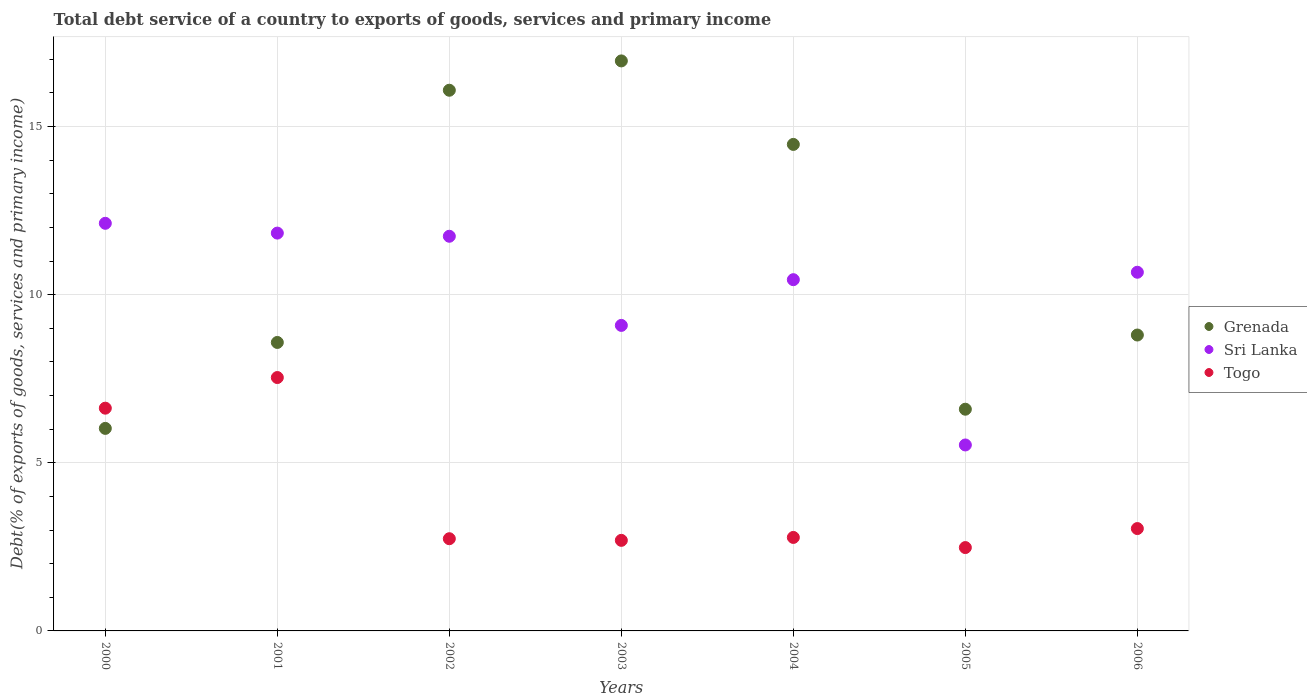What is the total debt service in Sri Lanka in 2002?
Make the answer very short. 11.74. Across all years, what is the maximum total debt service in Sri Lanka?
Offer a very short reply. 12.12. Across all years, what is the minimum total debt service in Sri Lanka?
Keep it short and to the point. 5.53. In which year was the total debt service in Grenada maximum?
Offer a terse response. 2003. In which year was the total debt service in Grenada minimum?
Offer a very short reply. 2000. What is the total total debt service in Sri Lanka in the graph?
Keep it short and to the point. 71.42. What is the difference between the total debt service in Grenada in 2002 and that in 2005?
Provide a succinct answer. 9.49. What is the difference between the total debt service in Togo in 2006 and the total debt service in Grenada in 2003?
Your answer should be very brief. -13.91. What is the average total debt service in Sri Lanka per year?
Provide a short and direct response. 10.2. In the year 2006, what is the difference between the total debt service in Togo and total debt service in Sri Lanka?
Make the answer very short. -7.62. In how many years, is the total debt service in Sri Lanka greater than 11 %?
Provide a short and direct response. 3. What is the ratio of the total debt service in Togo in 2000 to that in 2006?
Give a very brief answer. 2.18. Is the total debt service in Sri Lanka in 2003 less than that in 2006?
Your answer should be very brief. Yes. Is the difference between the total debt service in Togo in 2004 and 2005 greater than the difference between the total debt service in Sri Lanka in 2004 and 2005?
Your response must be concise. No. What is the difference between the highest and the second highest total debt service in Grenada?
Offer a very short reply. 0.87. What is the difference between the highest and the lowest total debt service in Grenada?
Your response must be concise. 10.93. In how many years, is the total debt service in Togo greater than the average total debt service in Togo taken over all years?
Keep it short and to the point. 2. Is the sum of the total debt service in Togo in 2002 and 2005 greater than the maximum total debt service in Grenada across all years?
Provide a short and direct response. No. How many dotlines are there?
Provide a succinct answer. 3. Where does the legend appear in the graph?
Keep it short and to the point. Center right. How many legend labels are there?
Ensure brevity in your answer.  3. How are the legend labels stacked?
Provide a short and direct response. Vertical. What is the title of the graph?
Your answer should be very brief. Total debt service of a country to exports of goods, services and primary income. Does "New Caledonia" appear as one of the legend labels in the graph?
Offer a terse response. No. What is the label or title of the Y-axis?
Give a very brief answer. Debt(% of exports of goods, services and primary income). What is the Debt(% of exports of goods, services and primary income) in Grenada in 2000?
Offer a terse response. 6.02. What is the Debt(% of exports of goods, services and primary income) of Sri Lanka in 2000?
Keep it short and to the point. 12.12. What is the Debt(% of exports of goods, services and primary income) in Togo in 2000?
Give a very brief answer. 6.62. What is the Debt(% of exports of goods, services and primary income) of Grenada in 2001?
Make the answer very short. 8.58. What is the Debt(% of exports of goods, services and primary income) in Sri Lanka in 2001?
Your response must be concise. 11.83. What is the Debt(% of exports of goods, services and primary income) of Togo in 2001?
Offer a very short reply. 7.54. What is the Debt(% of exports of goods, services and primary income) of Grenada in 2002?
Your answer should be very brief. 16.08. What is the Debt(% of exports of goods, services and primary income) in Sri Lanka in 2002?
Your answer should be very brief. 11.74. What is the Debt(% of exports of goods, services and primary income) of Togo in 2002?
Make the answer very short. 2.74. What is the Debt(% of exports of goods, services and primary income) of Grenada in 2003?
Keep it short and to the point. 16.95. What is the Debt(% of exports of goods, services and primary income) of Sri Lanka in 2003?
Provide a short and direct response. 9.09. What is the Debt(% of exports of goods, services and primary income) in Togo in 2003?
Provide a succinct answer. 2.69. What is the Debt(% of exports of goods, services and primary income) of Grenada in 2004?
Give a very brief answer. 14.47. What is the Debt(% of exports of goods, services and primary income) of Sri Lanka in 2004?
Offer a terse response. 10.45. What is the Debt(% of exports of goods, services and primary income) in Togo in 2004?
Keep it short and to the point. 2.78. What is the Debt(% of exports of goods, services and primary income) in Grenada in 2005?
Provide a succinct answer. 6.59. What is the Debt(% of exports of goods, services and primary income) in Sri Lanka in 2005?
Give a very brief answer. 5.53. What is the Debt(% of exports of goods, services and primary income) of Togo in 2005?
Make the answer very short. 2.48. What is the Debt(% of exports of goods, services and primary income) in Grenada in 2006?
Make the answer very short. 8.8. What is the Debt(% of exports of goods, services and primary income) in Sri Lanka in 2006?
Ensure brevity in your answer.  10.67. What is the Debt(% of exports of goods, services and primary income) of Togo in 2006?
Your response must be concise. 3.04. Across all years, what is the maximum Debt(% of exports of goods, services and primary income) in Grenada?
Provide a succinct answer. 16.95. Across all years, what is the maximum Debt(% of exports of goods, services and primary income) of Sri Lanka?
Make the answer very short. 12.12. Across all years, what is the maximum Debt(% of exports of goods, services and primary income) in Togo?
Your answer should be very brief. 7.54. Across all years, what is the minimum Debt(% of exports of goods, services and primary income) of Grenada?
Give a very brief answer. 6.02. Across all years, what is the minimum Debt(% of exports of goods, services and primary income) in Sri Lanka?
Offer a very short reply. 5.53. Across all years, what is the minimum Debt(% of exports of goods, services and primary income) of Togo?
Provide a short and direct response. 2.48. What is the total Debt(% of exports of goods, services and primary income) in Grenada in the graph?
Offer a very short reply. 77.5. What is the total Debt(% of exports of goods, services and primary income) of Sri Lanka in the graph?
Provide a short and direct response. 71.42. What is the total Debt(% of exports of goods, services and primary income) in Togo in the graph?
Offer a terse response. 27.9. What is the difference between the Debt(% of exports of goods, services and primary income) in Grenada in 2000 and that in 2001?
Offer a terse response. -2.56. What is the difference between the Debt(% of exports of goods, services and primary income) in Sri Lanka in 2000 and that in 2001?
Ensure brevity in your answer.  0.29. What is the difference between the Debt(% of exports of goods, services and primary income) in Togo in 2000 and that in 2001?
Provide a succinct answer. -0.91. What is the difference between the Debt(% of exports of goods, services and primary income) of Grenada in 2000 and that in 2002?
Your answer should be compact. -10.06. What is the difference between the Debt(% of exports of goods, services and primary income) in Sri Lanka in 2000 and that in 2002?
Provide a succinct answer. 0.39. What is the difference between the Debt(% of exports of goods, services and primary income) of Togo in 2000 and that in 2002?
Provide a short and direct response. 3.88. What is the difference between the Debt(% of exports of goods, services and primary income) of Grenada in 2000 and that in 2003?
Provide a short and direct response. -10.93. What is the difference between the Debt(% of exports of goods, services and primary income) in Sri Lanka in 2000 and that in 2003?
Provide a short and direct response. 3.04. What is the difference between the Debt(% of exports of goods, services and primary income) of Togo in 2000 and that in 2003?
Keep it short and to the point. 3.93. What is the difference between the Debt(% of exports of goods, services and primary income) in Grenada in 2000 and that in 2004?
Offer a very short reply. -8.45. What is the difference between the Debt(% of exports of goods, services and primary income) of Sri Lanka in 2000 and that in 2004?
Make the answer very short. 1.68. What is the difference between the Debt(% of exports of goods, services and primary income) of Togo in 2000 and that in 2004?
Your answer should be compact. 3.84. What is the difference between the Debt(% of exports of goods, services and primary income) of Grenada in 2000 and that in 2005?
Provide a short and direct response. -0.57. What is the difference between the Debt(% of exports of goods, services and primary income) in Sri Lanka in 2000 and that in 2005?
Make the answer very short. 6.59. What is the difference between the Debt(% of exports of goods, services and primary income) of Togo in 2000 and that in 2005?
Make the answer very short. 4.15. What is the difference between the Debt(% of exports of goods, services and primary income) in Grenada in 2000 and that in 2006?
Provide a short and direct response. -2.78. What is the difference between the Debt(% of exports of goods, services and primary income) of Sri Lanka in 2000 and that in 2006?
Your answer should be very brief. 1.46. What is the difference between the Debt(% of exports of goods, services and primary income) of Togo in 2000 and that in 2006?
Keep it short and to the point. 3.58. What is the difference between the Debt(% of exports of goods, services and primary income) in Grenada in 2001 and that in 2002?
Keep it short and to the point. -7.5. What is the difference between the Debt(% of exports of goods, services and primary income) of Sri Lanka in 2001 and that in 2002?
Provide a succinct answer. 0.09. What is the difference between the Debt(% of exports of goods, services and primary income) of Togo in 2001 and that in 2002?
Offer a terse response. 4.79. What is the difference between the Debt(% of exports of goods, services and primary income) of Grenada in 2001 and that in 2003?
Your answer should be compact. -8.37. What is the difference between the Debt(% of exports of goods, services and primary income) of Sri Lanka in 2001 and that in 2003?
Offer a very short reply. 2.75. What is the difference between the Debt(% of exports of goods, services and primary income) in Togo in 2001 and that in 2003?
Offer a very short reply. 4.84. What is the difference between the Debt(% of exports of goods, services and primary income) of Grenada in 2001 and that in 2004?
Make the answer very short. -5.89. What is the difference between the Debt(% of exports of goods, services and primary income) in Sri Lanka in 2001 and that in 2004?
Provide a succinct answer. 1.39. What is the difference between the Debt(% of exports of goods, services and primary income) of Togo in 2001 and that in 2004?
Ensure brevity in your answer.  4.76. What is the difference between the Debt(% of exports of goods, services and primary income) of Grenada in 2001 and that in 2005?
Your answer should be very brief. 1.99. What is the difference between the Debt(% of exports of goods, services and primary income) in Sri Lanka in 2001 and that in 2005?
Provide a succinct answer. 6.3. What is the difference between the Debt(% of exports of goods, services and primary income) of Togo in 2001 and that in 2005?
Provide a succinct answer. 5.06. What is the difference between the Debt(% of exports of goods, services and primary income) of Grenada in 2001 and that in 2006?
Your response must be concise. -0.22. What is the difference between the Debt(% of exports of goods, services and primary income) of Sri Lanka in 2001 and that in 2006?
Your answer should be compact. 1.16. What is the difference between the Debt(% of exports of goods, services and primary income) of Togo in 2001 and that in 2006?
Your response must be concise. 4.49. What is the difference between the Debt(% of exports of goods, services and primary income) of Grenada in 2002 and that in 2003?
Your response must be concise. -0.87. What is the difference between the Debt(% of exports of goods, services and primary income) in Sri Lanka in 2002 and that in 2003?
Your answer should be compact. 2.65. What is the difference between the Debt(% of exports of goods, services and primary income) in Togo in 2002 and that in 2003?
Your response must be concise. 0.05. What is the difference between the Debt(% of exports of goods, services and primary income) in Grenada in 2002 and that in 2004?
Offer a very short reply. 1.61. What is the difference between the Debt(% of exports of goods, services and primary income) in Sri Lanka in 2002 and that in 2004?
Make the answer very short. 1.29. What is the difference between the Debt(% of exports of goods, services and primary income) of Togo in 2002 and that in 2004?
Keep it short and to the point. -0.04. What is the difference between the Debt(% of exports of goods, services and primary income) in Grenada in 2002 and that in 2005?
Keep it short and to the point. 9.49. What is the difference between the Debt(% of exports of goods, services and primary income) in Sri Lanka in 2002 and that in 2005?
Provide a succinct answer. 6.21. What is the difference between the Debt(% of exports of goods, services and primary income) in Togo in 2002 and that in 2005?
Your answer should be compact. 0.26. What is the difference between the Debt(% of exports of goods, services and primary income) in Grenada in 2002 and that in 2006?
Your response must be concise. 7.28. What is the difference between the Debt(% of exports of goods, services and primary income) in Sri Lanka in 2002 and that in 2006?
Ensure brevity in your answer.  1.07. What is the difference between the Debt(% of exports of goods, services and primary income) of Togo in 2002 and that in 2006?
Offer a terse response. -0.3. What is the difference between the Debt(% of exports of goods, services and primary income) of Grenada in 2003 and that in 2004?
Ensure brevity in your answer.  2.48. What is the difference between the Debt(% of exports of goods, services and primary income) in Sri Lanka in 2003 and that in 2004?
Your answer should be very brief. -1.36. What is the difference between the Debt(% of exports of goods, services and primary income) of Togo in 2003 and that in 2004?
Offer a terse response. -0.09. What is the difference between the Debt(% of exports of goods, services and primary income) in Grenada in 2003 and that in 2005?
Keep it short and to the point. 10.36. What is the difference between the Debt(% of exports of goods, services and primary income) of Sri Lanka in 2003 and that in 2005?
Ensure brevity in your answer.  3.56. What is the difference between the Debt(% of exports of goods, services and primary income) in Togo in 2003 and that in 2005?
Your response must be concise. 0.21. What is the difference between the Debt(% of exports of goods, services and primary income) of Grenada in 2003 and that in 2006?
Provide a short and direct response. 8.15. What is the difference between the Debt(% of exports of goods, services and primary income) in Sri Lanka in 2003 and that in 2006?
Make the answer very short. -1.58. What is the difference between the Debt(% of exports of goods, services and primary income) in Togo in 2003 and that in 2006?
Ensure brevity in your answer.  -0.35. What is the difference between the Debt(% of exports of goods, services and primary income) in Grenada in 2004 and that in 2005?
Provide a succinct answer. 7.88. What is the difference between the Debt(% of exports of goods, services and primary income) in Sri Lanka in 2004 and that in 2005?
Provide a short and direct response. 4.92. What is the difference between the Debt(% of exports of goods, services and primary income) in Togo in 2004 and that in 2005?
Provide a succinct answer. 0.3. What is the difference between the Debt(% of exports of goods, services and primary income) of Grenada in 2004 and that in 2006?
Make the answer very short. 5.67. What is the difference between the Debt(% of exports of goods, services and primary income) of Sri Lanka in 2004 and that in 2006?
Provide a succinct answer. -0.22. What is the difference between the Debt(% of exports of goods, services and primary income) in Togo in 2004 and that in 2006?
Offer a terse response. -0.26. What is the difference between the Debt(% of exports of goods, services and primary income) of Grenada in 2005 and that in 2006?
Offer a terse response. -2.21. What is the difference between the Debt(% of exports of goods, services and primary income) of Sri Lanka in 2005 and that in 2006?
Your response must be concise. -5.14. What is the difference between the Debt(% of exports of goods, services and primary income) in Togo in 2005 and that in 2006?
Offer a very short reply. -0.57. What is the difference between the Debt(% of exports of goods, services and primary income) in Grenada in 2000 and the Debt(% of exports of goods, services and primary income) in Sri Lanka in 2001?
Provide a succinct answer. -5.81. What is the difference between the Debt(% of exports of goods, services and primary income) in Grenada in 2000 and the Debt(% of exports of goods, services and primary income) in Togo in 2001?
Your answer should be compact. -1.51. What is the difference between the Debt(% of exports of goods, services and primary income) of Sri Lanka in 2000 and the Debt(% of exports of goods, services and primary income) of Togo in 2001?
Keep it short and to the point. 4.59. What is the difference between the Debt(% of exports of goods, services and primary income) of Grenada in 2000 and the Debt(% of exports of goods, services and primary income) of Sri Lanka in 2002?
Give a very brief answer. -5.71. What is the difference between the Debt(% of exports of goods, services and primary income) of Grenada in 2000 and the Debt(% of exports of goods, services and primary income) of Togo in 2002?
Your response must be concise. 3.28. What is the difference between the Debt(% of exports of goods, services and primary income) in Sri Lanka in 2000 and the Debt(% of exports of goods, services and primary income) in Togo in 2002?
Your answer should be very brief. 9.38. What is the difference between the Debt(% of exports of goods, services and primary income) in Grenada in 2000 and the Debt(% of exports of goods, services and primary income) in Sri Lanka in 2003?
Give a very brief answer. -3.06. What is the difference between the Debt(% of exports of goods, services and primary income) of Grenada in 2000 and the Debt(% of exports of goods, services and primary income) of Togo in 2003?
Your answer should be very brief. 3.33. What is the difference between the Debt(% of exports of goods, services and primary income) in Sri Lanka in 2000 and the Debt(% of exports of goods, services and primary income) in Togo in 2003?
Your answer should be compact. 9.43. What is the difference between the Debt(% of exports of goods, services and primary income) in Grenada in 2000 and the Debt(% of exports of goods, services and primary income) in Sri Lanka in 2004?
Give a very brief answer. -4.42. What is the difference between the Debt(% of exports of goods, services and primary income) of Grenada in 2000 and the Debt(% of exports of goods, services and primary income) of Togo in 2004?
Make the answer very short. 3.24. What is the difference between the Debt(% of exports of goods, services and primary income) in Sri Lanka in 2000 and the Debt(% of exports of goods, services and primary income) in Togo in 2004?
Keep it short and to the point. 9.34. What is the difference between the Debt(% of exports of goods, services and primary income) in Grenada in 2000 and the Debt(% of exports of goods, services and primary income) in Sri Lanka in 2005?
Provide a short and direct response. 0.49. What is the difference between the Debt(% of exports of goods, services and primary income) in Grenada in 2000 and the Debt(% of exports of goods, services and primary income) in Togo in 2005?
Give a very brief answer. 3.54. What is the difference between the Debt(% of exports of goods, services and primary income) of Sri Lanka in 2000 and the Debt(% of exports of goods, services and primary income) of Togo in 2005?
Offer a terse response. 9.64. What is the difference between the Debt(% of exports of goods, services and primary income) of Grenada in 2000 and the Debt(% of exports of goods, services and primary income) of Sri Lanka in 2006?
Offer a very short reply. -4.64. What is the difference between the Debt(% of exports of goods, services and primary income) of Grenada in 2000 and the Debt(% of exports of goods, services and primary income) of Togo in 2006?
Make the answer very short. 2.98. What is the difference between the Debt(% of exports of goods, services and primary income) of Sri Lanka in 2000 and the Debt(% of exports of goods, services and primary income) of Togo in 2006?
Keep it short and to the point. 9.08. What is the difference between the Debt(% of exports of goods, services and primary income) in Grenada in 2001 and the Debt(% of exports of goods, services and primary income) in Sri Lanka in 2002?
Offer a terse response. -3.16. What is the difference between the Debt(% of exports of goods, services and primary income) in Grenada in 2001 and the Debt(% of exports of goods, services and primary income) in Togo in 2002?
Make the answer very short. 5.84. What is the difference between the Debt(% of exports of goods, services and primary income) in Sri Lanka in 2001 and the Debt(% of exports of goods, services and primary income) in Togo in 2002?
Provide a short and direct response. 9.09. What is the difference between the Debt(% of exports of goods, services and primary income) in Grenada in 2001 and the Debt(% of exports of goods, services and primary income) in Sri Lanka in 2003?
Give a very brief answer. -0.51. What is the difference between the Debt(% of exports of goods, services and primary income) of Grenada in 2001 and the Debt(% of exports of goods, services and primary income) of Togo in 2003?
Your answer should be compact. 5.89. What is the difference between the Debt(% of exports of goods, services and primary income) in Sri Lanka in 2001 and the Debt(% of exports of goods, services and primary income) in Togo in 2003?
Provide a succinct answer. 9.14. What is the difference between the Debt(% of exports of goods, services and primary income) in Grenada in 2001 and the Debt(% of exports of goods, services and primary income) in Sri Lanka in 2004?
Provide a short and direct response. -1.87. What is the difference between the Debt(% of exports of goods, services and primary income) in Grenada in 2001 and the Debt(% of exports of goods, services and primary income) in Togo in 2004?
Ensure brevity in your answer.  5.8. What is the difference between the Debt(% of exports of goods, services and primary income) of Sri Lanka in 2001 and the Debt(% of exports of goods, services and primary income) of Togo in 2004?
Provide a succinct answer. 9.05. What is the difference between the Debt(% of exports of goods, services and primary income) of Grenada in 2001 and the Debt(% of exports of goods, services and primary income) of Sri Lanka in 2005?
Provide a short and direct response. 3.05. What is the difference between the Debt(% of exports of goods, services and primary income) in Grenada in 2001 and the Debt(% of exports of goods, services and primary income) in Togo in 2005?
Your answer should be very brief. 6.1. What is the difference between the Debt(% of exports of goods, services and primary income) of Sri Lanka in 2001 and the Debt(% of exports of goods, services and primary income) of Togo in 2005?
Keep it short and to the point. 9.35. What is the difference between the Debt(% of exports of goods, services and primary income) of Grenada in 2001 and the Debt(% of exports of goods, services and primary income) of Sri Lanka in 2006?
Make the answer very short. -2.09. What is the difference between the Debt(% of exports of goods, services and primary income) of Grenada in 2001 and the Debt(% of exports of goods, services and primary income) of Togo in 2006?
Your answer should be compact. 5.54. What is the difference between the Debt(% of exports of goods, services and primary income) of Sri Lanka in 2001 and the Debt(% of exports of goods, services and primary income) of Togo in 2006?
Your answer should be very brief. 8.79. What is the difference between the Debt(% of exports of goods, services and primary income) of Grenada in 2002 and the Debt(% of exports of goods, services and primary income) of Sri Lanka in 2003?
Give a very brief answer. 6.99. What is the difference between the Debt(% of exports of goods, services and primary income) of Grenada in 2002 and the Debt(% of exports of goods, services and primary income) of Togo in 2003?
Provide a succinct answer. 13.39. What is the difference between the Debt(% of exports of goods, services and primary income) of Sri Lanka in 2002 and the Debt(% of exports of goods, services and primary income) of Togo in 2003?
Your answer should be compact. 9.04. What is the difference between the Debt(% of exports of goods, services and primary income) of Grenada in 2002 and the Debt(% of exports of goods, services and primary income) of Sri Lanka in 2004?
Ensure brevity in your answer.  5.63. What is the difference between the Debt(% of exports of goods, services and primary income) of Grenada in 2002 and the Debt(% of exports of goods, services and primary income) of Togo in 2004?
Provide a succinct answer. 13.3. What is the difference between the Debt(% of exports of goods, services and primary income) in Sri Lanka in 2002 and the Debt(% of exports of goods, services and primary income) in Togo in 2004?
Make the answer very short. 8.96. What is the difference between the Debt(% of exports of goods, services and primary income) of Grenada in 2002 and the Debt(% of exports of goods, services and primary income) of Sri Lanka in 2005?
Provide a succinct answer. 10.55. What is the difference between the Debt(% of exports of goods, services and primary income) in Grenada in 2002 and the Debt(% of exports of goods, services and primary income) in Togo in 2005?
Offer a terse response. 13.6. What is the difference between the Debt(% of exports of goods, services and primary income) in Sri Lanka in 2002 and the Debt(% of exports of goods, services and primary income) in Togo in 2005?
Offer a very short reply. 9.26. What is the difference between the Debt(% of exports of goods, services and primary income) of Grenada in 2002 and the Debt(% of exports of goods, services and primary income) of Sri Lanka in 2006?
Your answer should be compact. 5.41. What is the difference between the Debt(% of exports of goods, services and primary income) in Grenada in 2002 and the Debt(% of exports of goods, services and primary income) in Togo in 2006?
Offer a very short reply. 13.04. What is the difference between the Debt(% of exports of goods, services and primary income) of Sri Lanka in 2002 and the Debt(% of exports of goods, services and primary income) of Togo in 2006?
Your answer should be very brief. 8.69. What is the difference between the Debt(% of exports of goods, services and primary income) of Grenada in 2003 and the Debt(% of exports of goods, services and primary income) of Sri Lanka in 2004?
Ensure brevity in your answer.  6.51. What is the difference between the Debt(% of exports of goods, services and primary income) of Grenada in 2003 and the Debt(% of exports of goods, services and primary income) of Togo in 2004?
Offer a terse response. 14.17. What is the difference between the Debt(% of exports of goods, services and primary income) of Sri Lanka in 2003 and the Debt(% of exports of goods, services and primary income) of Togo in 2004?
Make the answer very short. 6.31. What is the difference between the Debt(% of exports of goods, services and primary income) in Grenada in 2003 and the Debt(% of exports of goods, services and primary income) in Sri Lanka in 2005?
Ensure brevity in your answer.  11.42. What is the difference between the Debt(% of exports of goods, services and primary income) of Grenada in 2003 and the Debt(% of exports of goods, services and primary income) of Togo in 2005?
Ensure brevity in your answer.  14.47. What is the difference between the Debt(% of exports of goods, services and primary income) in Sri Lanka in 2003 and the Debt(% of exports of goods, services and primary income) in Togo in 2005?
Your response must be concise. 6.61. What is the difference between the Debt(% of exports of goods, services and primary income) in Grenada in 2003 and the Debt(% of exports of goods, services and primary income) in Sri Lanka in 2006?
Provide a short and direct response. 6.29. What is the difference between the Debt(% of exports of goods, services and primary income) in Grenada in 2003 and the Debt(% of exports of goods, services and primary income) in Togo in 2006?
Your response must be concise. 13.91. What is the difference between the Debt(% of exports of goods, services and primary income) of Sri Lanka in 2003 and the Debt(% of exports of goods, services and primary income) of Togo in 2006?
Your answer should be compact. 6.04. What is the difference between the Debt(% of exports of goods, services and primary income) of Grenada in 2004 and the Debt(% of exports of goods, services and primary income) of Sri Lanka in 2005?
Provide a succinct answer. 8.94. What is the difference between the Debt(% of exports of goods, services and primary income) of Grenada in 2004 and the Debt(% of exports of goods, services and primary income) of Togo in 2005?
Provide a succinct answer. 11.99. What is the difference between the Debt(% of exports of goods, services and primary income) of Sri Lanka in 2004 and the Debt(% of exports of goods, services and primary income) of Togo in 2005?
Ensure brevity in your answer.  7.97. What is the difference between the Debt(% of exports of goods, services and primary income) in Grenada in 2004 and the Debt(% of exports of goods, services and primary income) in Sri Lanka in 2006?
Your answer should be compact. 3.8. What is the difference between the Debt(% of exports of goods, services and primary income) of Grenada in 2004 and the Debt(% of exports of goods, services and primary income) of Togo in 2006?
Offer a very short reply. 11.43. What is the difference between the Debt(% of exports of goods, services and primary income) of Sri Lanka in 2004 and the Debt(% of exports of goods, services and primary income) of Togo in 2006?
Your response must be concise. 7.4. What is the difference between the Debt(% of exports of goods, services and primary income) in Grenada in 2005 and the Debt(% of exports of goods, services and primary income) in Sri Lanka in 2006?
Provide a succinct answer. -4.07. What is the difference between the Debt(% of exports of goods, services and primary income) of Grenada in 2005 and the Debt(% of exports of goods, services and primary income) of Togo in 2006?
Your response must be concise. 3.55. What is the difference between the Debt(% of exports of goods, services and primary income) of Sri Lanka in 2005 and the Debt(% of exports of goods, services and primary income) of Togo in 2006?
Provide a short and direct response. 2.49. What is the average Debt(% of exports of goods, services and primary income) in Grenada per year?
Your response must be concise. 11.07. What is the average Debt(% of exports of goods, services and primary income) of Sri Lanka per year?
Ensure brevity in your answer.  10.2. What is the average Debt(% of exports of goods, services and primary income) in Togo per year?
Offer a terse response. 3.99. In the year 2000, what is the difference between the Debt(% of exports of goods, services and primary income) in Grenada and Debt(% of exports of goods, services and primary income) in Sri Lanka?
Offer a very short reply. -6.1. In the year 2000, what is the difference between the Debt(% of exports of goods, services and primary income) of Grenada and Debt(% of exports of goods, services and primary income) of Togo?
Make the answer very short. -0.6. In the year 2000, what is the difference between the Debt(% of exports of goods, services and primary income) of Sri Lanka and Debt(% of exports of goods, services and primary income) of Togo?
Your answer should be compact. 5.5. In the year 2001, what is the difference between the Debt(% of exports of goods, services and primary income) in Grenada and Debt(% of exports of goods, services and primary income) in Sri Lanka?
Your answer should be very brief. -3.25. In the year 2001, what is the difference between the Debt(% of exports of goods, services and primary income) of Grenada and Debt(% of exports of goods, services and primary income) of Togo?
Your answer should be compact. 1.04. In the year 2001, what is the difference between the Debt(% of exports of goods, services and primary income) in Sri Lanka and Debt(% of exports of goods, services and primary income) in Togo?
Ensure brevity in your answer.  4.3. In the year 2002, what is the difference between the Debt(% of exports of goods, services and primary income) in Grenada and Debt(% of exports of goods, services and primary income) in Sri Lanka?
Your response must be concise. 4.34. In the year 2002, what is the difference between the Debt(% of exports of goods, services and primary income) in Grenada and Debt(% of exports of goods, services and primary income) in Togo?
Offer a terse response. 13.34. In the year 2002, what is the difference between the Debt(% of exports of goods, services and primary income) of Sri Lanka and Debt(% of exports of goods, services and primary income) of Togo?
Your answer should be compact. 9. In the year 2003, what is the difference between the Debt(% of exports of goods, services and primary income) of Grenada and Debt(% of exports of goods, services and primary income) of Sri Lanka?
Provide a short and direct response. 7.87. In the year 2003, what is the difference between the Debt(% of exports of goods, services and primary income) of Grenada and Debt(% of exports of goods, services and primary income) of Togo?
Keep it short and to the point. 14.26. In the year 2003, what is the difference between the Debt(% of exports of goods, services and primary income) of Sri Lanka and Debt(% of exports of goods, services and primary income) of Togo?
Ensure brevity in your answer.  6.39. In the year 2004, what is the difference between the Debt(% of exports of goods, services and primary income) in Grenada and Debt(% of exports of goods, services and primary income) in Sri Lanka?
Offer a terse response. 4.02. In the year 2004, what is the difference between the Debt(% of exports of goods, services and primary income) in Grenada and Debt(% of exports of goods, services and primary income) in Togo?
Offer a terse response. 11.69. In the year 2004, what is the difference between the Debt(% of exports of goods, services and primary income) of Sri Lanka and Debt(% of exports of goods, services and primary income) of Togo?
Make the answer very short. 7.67. In the year 2005, what is the difference between the Debt(% of exports of goods, services and primary income) in Grenada and Debt(% of exports of goods, services and primary income) in Sri Lanka?
Provide a succinct answer. 1.06. In the year 2005, what is the difference between the Debt(% of exports of goods, services and primary income) in Grenada and Debt(% of exports of goods, services and primary income) in Togo?
Give a very brief answer. 4.12. In the year 2005, what is the difference between the Debt(% of exports of goods, services and primary income) of Sri Lanka and Debt(% of exports of goods, services and primary income) of Togo?
Offer a terse response. 3.05. In the year 2006, what is the difference between the Debt(% of exports of goods, services and primary income) of Grenada and Debt(% of exports of goods, services and primary income) of Sri Lanka?
Your answer should be very brief. -1.87. In the year 2006, what is the difference between the Debt(% of exports of goods, services and primary income) of Grenada and Debt(% of exports of goods, services and primary income) of Togo?
Your answer should be compact. 5.76. In the year 2006, what is the difference between the Debt(% of exports of goods, services and primary income) in Sri Lanka and Debt(% of exports of goods, services and primary income) in Togo?
Make the answer very short. 7.62. What is the ratio of the Debt(% of exports of goods, services and primary income) of Grenada in 2000 to that in 2001?
Keep it short and to the point. 0.7. What is the ratio of the Debt(% of exports of goods, services and primary income) in Sri Lanka in 2000 to that in 2001?
Your response must be concise. 1.02. What is the ratio of the Debt(% of exports of goods, services and primary income) of Togo in 2000 to that in 2001?
Offer a terse response. 0.88. What is the ratio of the Debt(% of exports of goods, services and primary income) in Grenada in 2000 to that in 2002?
Your answer should be very brief. 0.37. What is the ratio of the Debt(% of exports of goods, services and primary income) of Sri Lanka in 2000 to that in 2002?
Offer a very short reply. 1.03. What is the ratio of the Debt(% of exports of goods, services and primary income) of Togo in 2000 to that in 2002?
Your answer should be compact. 2.42. What is the ratio of the Debt(% of exports of goods, services and primary income) in Grenada in 2000 to that in 2003?
Give a very brief answer. 0.36. What is the ratio of the Debt(% of exports of goods, services and primary income) in Sri Lanka in 2000 to that in 2003?
Your response must be concise. 1.33. What is the ratio of the Debt(% of exports of goods, services and primary income) in Togo in 2000 to that in 2003?
Provide a succinct answer. 2.46. What is the ratio of the Debt(% of exports of goods, services and primary income) of Grenada in 2000 to that in 2004?
Offer a terse response. 0.42. What is the ratio of the Debt(% of exports of goods, services and primary income) of Sri Lanka in 2000 to that in 2004?
Your response must be concise. 1.16. What is the ratio of the Debt(% of exports of goods, services and primary income) of Togo in 2000 to that in 2004?
Your answer should be compact. 2.38. What is the ratio of the Debt(% of exports of goods, services and primary income) in Grenada in 2000 to that in 2005?
Give a very brief answer. 0.91. What is the ratio of the Debt(% of exports of goods, services and primary income) of Sri Lanka in 2000 to that in 2005?
Ensure brevity in your answer.  2.19. What is the ratio of the Debt(% of exports of goods, services and primary income) of Togo in 2000 to that in 2005?
Keep it short and to the point. 2.67. What is the ratio of the Debt(% of exports of goods, services and primary income) of Grenada in 2000 to that in 2006?
Give a very brief answer. 0.68. What is the ratio of the Debt(% of exports of goods, services and primary income) in Sri Lanka in 2000 to that in 2006?
Your response must be concise. 1.14. What is the ratio of the Debt(% of exports of goods, services and primary income) of Togo in 2000 to that in 2006?
Make the answer very short. 2.18. What is the ratio of the Debt(% of exports of goods, services and primary income) of Grenada in 2001 to that in 2002?
Offer a terse response. 0.53. What is the ratio of the Debt(% of exports of goods, services and primary income) of Sri Lanka in 2001 to that in 2002?
Keep it short and to the point. 1.01. What is the ratio of the Debt(% of exports of goods, services and primary income) in Togo in 2001 to that in 2002?
Make the answer very short. 2.75. What is the ratio of the Debt(% of exports of goods, services and primary income) of Grenada in 2001 to that in 2003?
Provide a short and direct response. 0.51. What is the ratio of the Debt(% of exports of goods, services and primary income) of Sri Lanka in 2001 to that in 2003?
Your response must be concise. 1.3. What is the ratio of the Debt(% of exports of goods, services and primary income) in Togo in 2001 to that in 2003?
Make the answer very short. 2.8. What is the ratio of the Debt(% of exports of goods, services and primary income) in Grenada in 2001 to that in 2004?
Keep it short and to the point. 0.59. What is the ratio of the Debt(% of exports of goods, services and primary income) of Sri Lanka in 2001 to that in 2004?
Keep it short and to the point. 1.13. What is the ratio of the Debt(% of exports of goods, services and primary income) of Togo in 2001 to that in 2004?
Provide a short and direct response. 2.71. What is the ratio of the Debt(% of exports of goods, services and primary income) of Grenada in 2001 to that in 2005?
Ensure brevity in your answer.  1.3. What is the ratio of the Debt(% of exports of goods, services and primary income) in Sri Lanka in 2001 to that in 2005?
Provide a short and direct response. 2.14. What is the ratio of the Debt(% of exports of goods, services and primary income) of Togo in 2001 to that in 2005?
Make the answer very short. 3.04. What is the ratio of the Debt(% of exports of goods, services and primary income) in Grenada in 2001 to that in 2006?
Make the answer very short. 0.97. What is the ratio of the Debt(% of exports of goods, services and primary income) of Sri Lanka in 2001 to that in 2006?
Provide a short and direct response. 1.11. What is the ratio of the Debt(% of exports of goods, services and primary income) in Togo in 2001 to that in 2006?
Your answer should be compact. 2.48. What is the ratio of the Debt(% of exports of goods, services and primary income) of Grenada in 2002 to that in 2003?
Your response must be concise. 0.95. What is the ratio of the Debt(% of exports of goods, services and primary income) of Sri Lanka in 2002 to that in 2003?
Provide a short and direct response. 1.29. What is the ratio of the Debt(% of exports of goods, services and primary income) in Togo in 2002 to that in 2003?
Offer a very short reply. 1.02. What is the ratio of the Debt(% of exports of goods, services and primary income) in Grenada in 2002 to that in 2004?
Ensure brevity in your answer.  1.11. What is the ratio of the Debt(% of exports of goods, services and primary income) in Sri Lanka in 2002 to that in 2004?
Provide a short and direct response. 1.12. What is the ratio of the Debt(% of exports of goods, services and primary income) of Togo in 2002 to that in 2004?
Keep it short and to the point. 0.99. What is the ratio of the Debt(% of exports of goods, services and primary income) of Grenada in 2002 to that in 2005?
Your answer should be very brief. 2.44. What is the ratio of the Debt(% of exports of goods, services and primary income) of Sri Lanka in 2002 to that in 2005?
Your response must be concise. 2.12. What is the ratio of the Debt(% of exports of goods, services and primary income) in Togo in 2002 to that in 2005?
Keep it short and to the point. 1.11. What is the ratio of the Debt(% of exports of goods, services and primary income) in Grenada in 2002 to that in 2006?
Provide a short and direct response. 1.83. What is the ratio of the Debt(% of exports of goods, services and primary income) in Sri Lanka in 2002 to that in 2006?
Make the answer very short. 1.1. What is the ratio of the Debt(% of exports of goods, services and primary income) in Togo in 2002 to that in 2006?
Ensure brevity in your answer.  0.9. What is the ratio of the Debt(% of exports of goods, services and primary income) of Grenada in 2003 to that in 2004?
Give a very brief answer. 1.17. What is the ratio of the Debt(% of exports of goods, services and primary income) of Sri Lanka in 2003 to that in 2004?
Your answer should be compact. 0.87. What is the ratio of the Debt(% of exports of goods, services and primary income) of Togo in 2003 to that in 2004?
Make the answer very short. 0.97. What is the ratio of the Debt(% of exports of goods, services and primary income) of Grenada in 2003 to that in 2005?
Offer a very short reply. 2.57. What is the ratio of the Debt(% of exports of goods, services and primary income) in Sri Lanka in 2003 to that in 2005?
Ensure brevity in your answer.  1.64. What is the ratio of the Debt(% of exports of goods, services and primary income) in Togo in 2003 to that in 2005?
Your answer should be compact. 1.09. What is the ratio of the Debt(% of exports of goods, services and primary income) in Grenada in 2003 to that in 2006?
Keep it short and to the point. 1.93. What is the ratio of the Debt(% of exports of goods, services and primary income) of Sri Lanka in 2003 to that in 2006?
Provide a succinct answer. 0.85. What is the ratio of the Debt(% of exports of goods, services and primary income) of Togo in 2003 to that in 2006?
Make the answer very short. 0.88. What is the ratio of the Debt(% of exports of goods, services and primary income) of Grenada in 2004 to that in 2005?
Give a very brief answer. 2.19. What is the ratio of the Debt(% of exports of goods, services and primary income) of Sri Lanka in 2004 to that in 2005?
Your answer should be very brief. 1.89. What is the ratio of the Debt(% of exports of goods, services and primary income) of Togo in 2004 to that in 2005?
Your answer should be compact. 1.12. What is the ratio of the Debt(% of exports of goods, services and primary income) in Grenada in 2004 to that in 2006?
Make the answer very short. 1.64. What is the ratio of the Debt(% of exports of goods, services and primary income) in Sri Lanka in 2004 to that in 2006?
Keep it short and to the point. 0.98. What is the ratio of the Debt(% of exports of goods, services and primary income) in Togo in 2004 to that in 2006?
Ensure brevity in your answer.  0.91. What is the ratio of the Debt(% of exports of goods, services and primary income) of Grenada in 2005 to that in 2006?
Provide a short and direct response. 0.75. What is the ratio of the Debt(% of exports of goods, services and primary income) in Sri Lanka in 2005 to that in 2006?
Ensure brevity in your answer.  0.52. What is the ratio of the Debt(% of exports of goods, services and primary income) of Togo in 2005 to that in 2006?
Give a very brief answer. 0.81. What is the difference between the highest and the second highest Debt(% of exports of goods, services and primary income) of Grenada?
Keep it short and to the point. 0.87. What is the difference between the highest and the second highest Debt(% of exports of goods, services and primary income) of Sri Lanka?
Provide a short and direct response. 0.29. What is the difference between the highest and the second highest Debt(% of exports of goods, services and primary income) of Togo?
Your answer should be very brief. 0.91. What is the difference between the highest and the lowest Debt(% of exports of goods, services and primary income) of Grenada?
Keep it short and to the point. 10.93. What is the difference between the highest and the lowest Debt(% of exports of goods, services and primary income) of Sri Lanka?
Your answer should be very brief. 6.59. What is the difference between the highest and the lowest Debt(% of exports of goods, services and primary income) in Togo?
Your answer should be compact. 5.06. 